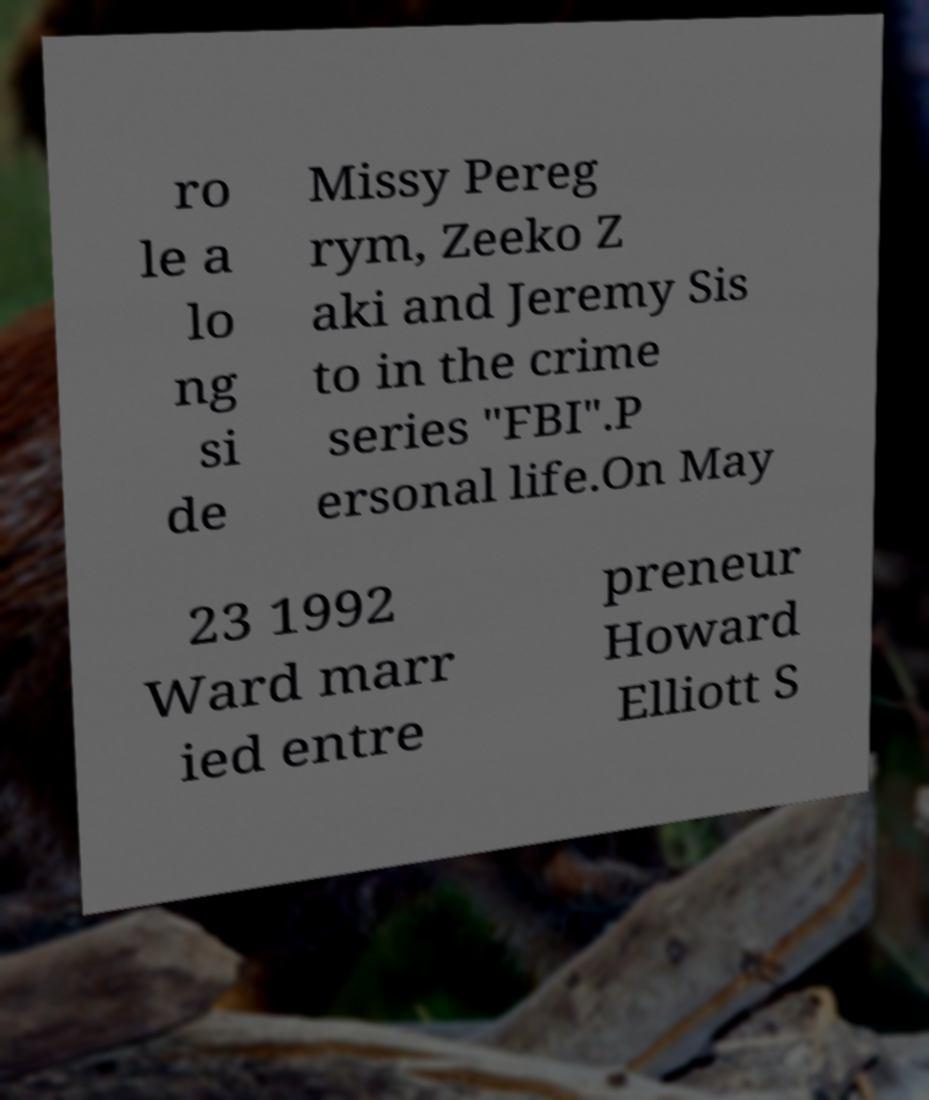For documentation purposes, I need the text within this image transcribed. Could you provide that? ro le a lo ng si de Missy Pereg rym, Zeeko Z aki and Jeremy Sis to in the crime series "FBI".P ersonal life.On May 23 1992 Ward marr ied entre preneur Howard Elliott S 